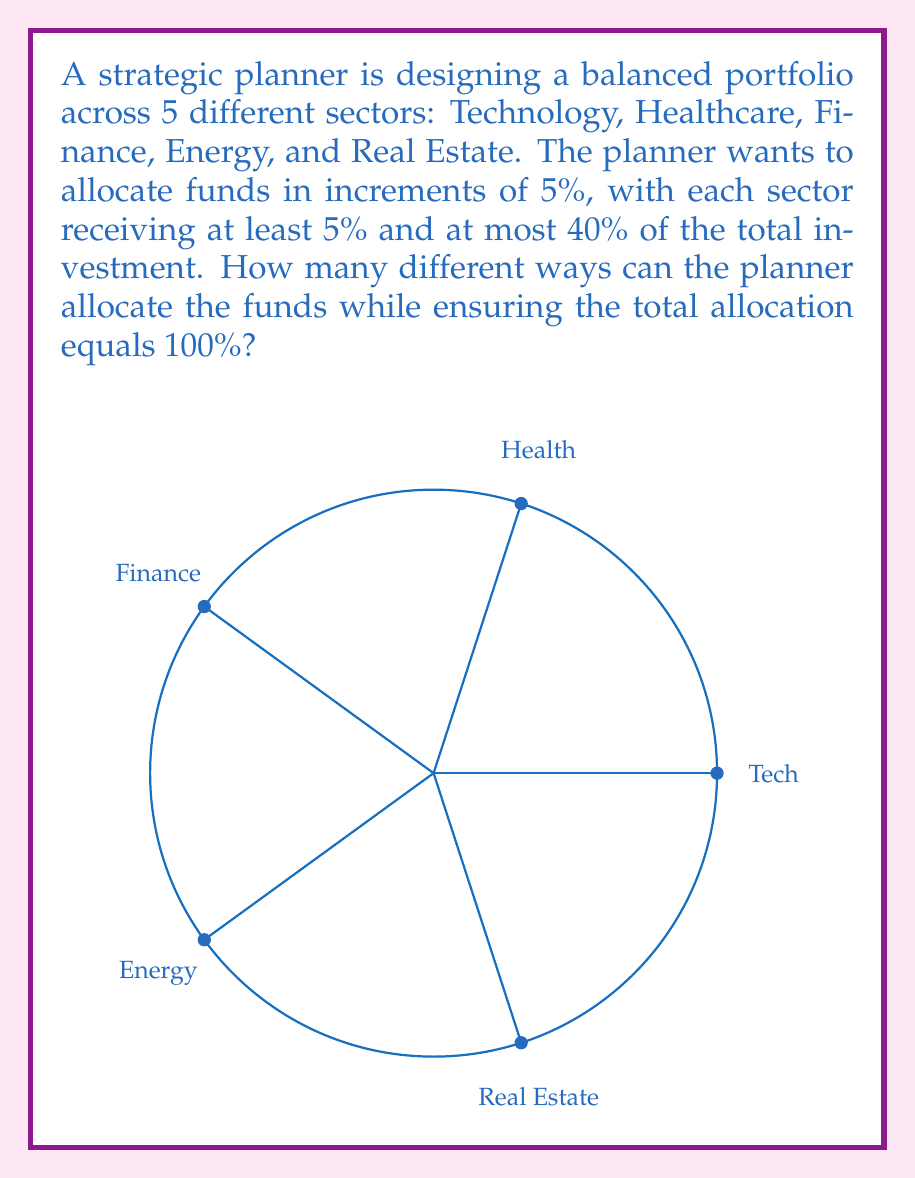Help me with this question. Let's approach this step-by-step:

1) First, we need to understand the constraints:
   - There are 5 sectors
   - Allocations are in 5% increments
   - Each sector gets at least 5% and at most 40%
   - The total allocation must sum to 100%

2) This problem can be solved using the stars and bars method in combinatorics, with some modifications due to the constraints.

3) Let's represent each 5% increment as a star. Since we're allocating 100%, we have 20 stars in total (100% / 5% = 20).

4) We need to distribute these 20 stars among 5 sectors (bars), with each sector getting at least 1 star (5%) and at most 8 stars (40%).

5) To account for the minimum allocation, we can first give each sector 1 star. This leaves us with 15 stars to distribute (20 - 5 = 15).

6) Now, we need to distribute 15 stars among 5 sectors, ensuring no sector gets more than 7 additional stars (to stay within the 40% maximum).

7) This is equivalent to finding the number of integer solutions to the equation:

   $$x_1 + x_2 + x_3 + x_4 + x_5 = 15$$

   where $0 \leq x_i \leq 7$ for all $i$.

8) This is a classic stars and bars problem with upper bounds, which can be solved using the Inclusion-Exclusion Principle.

9) Let $A_i$ be the set of solutions where $x_i \geq 8$. We want to find:

   $$|U| - |A_1 \cup A_2 \cup A_3 \cup A_4 \cup A_5|$$

   where $|U|$ is the total number of unrestricted solutions.

10) Using the Principle of Inclusion-Exclusion:

    $$|A_1 \cup A_2 \cup A_3 \cup A_4 \cup A_5| = \sum_{i=1}^5 |A_i| - \sum_{i<j} |A_i \cap A_j| + \sum_{i<j<k} |A_i \cap A_j \cap A_k| - \sum_{i<j<k<l} |A_i \cap A_j \cap A_k \cap A_l| + |A_1 \cap A_2 \cap A_3 \cap A_4 \cap A_5|$$

11) Calculating each term:
    - $|U| = \binom{19}{4} = 3876$
    - $|A_i| = \binom{12}{4} = 495$ (5 times)
    - $|A_i \cap A_j| = \binom{5}{4} = 5$ (10 times)
    - All other intersections are 0 as it's impossible to have two or more sectors exceed 7 stars.

12) Putting it all together:
    $$3876 - (5 \cdot 495 - 10 \cdot 5) = 3876 - 2425 = 1451$$

Therefore, there are 1451 different ways to allocate the funds.
Answer: 1451 